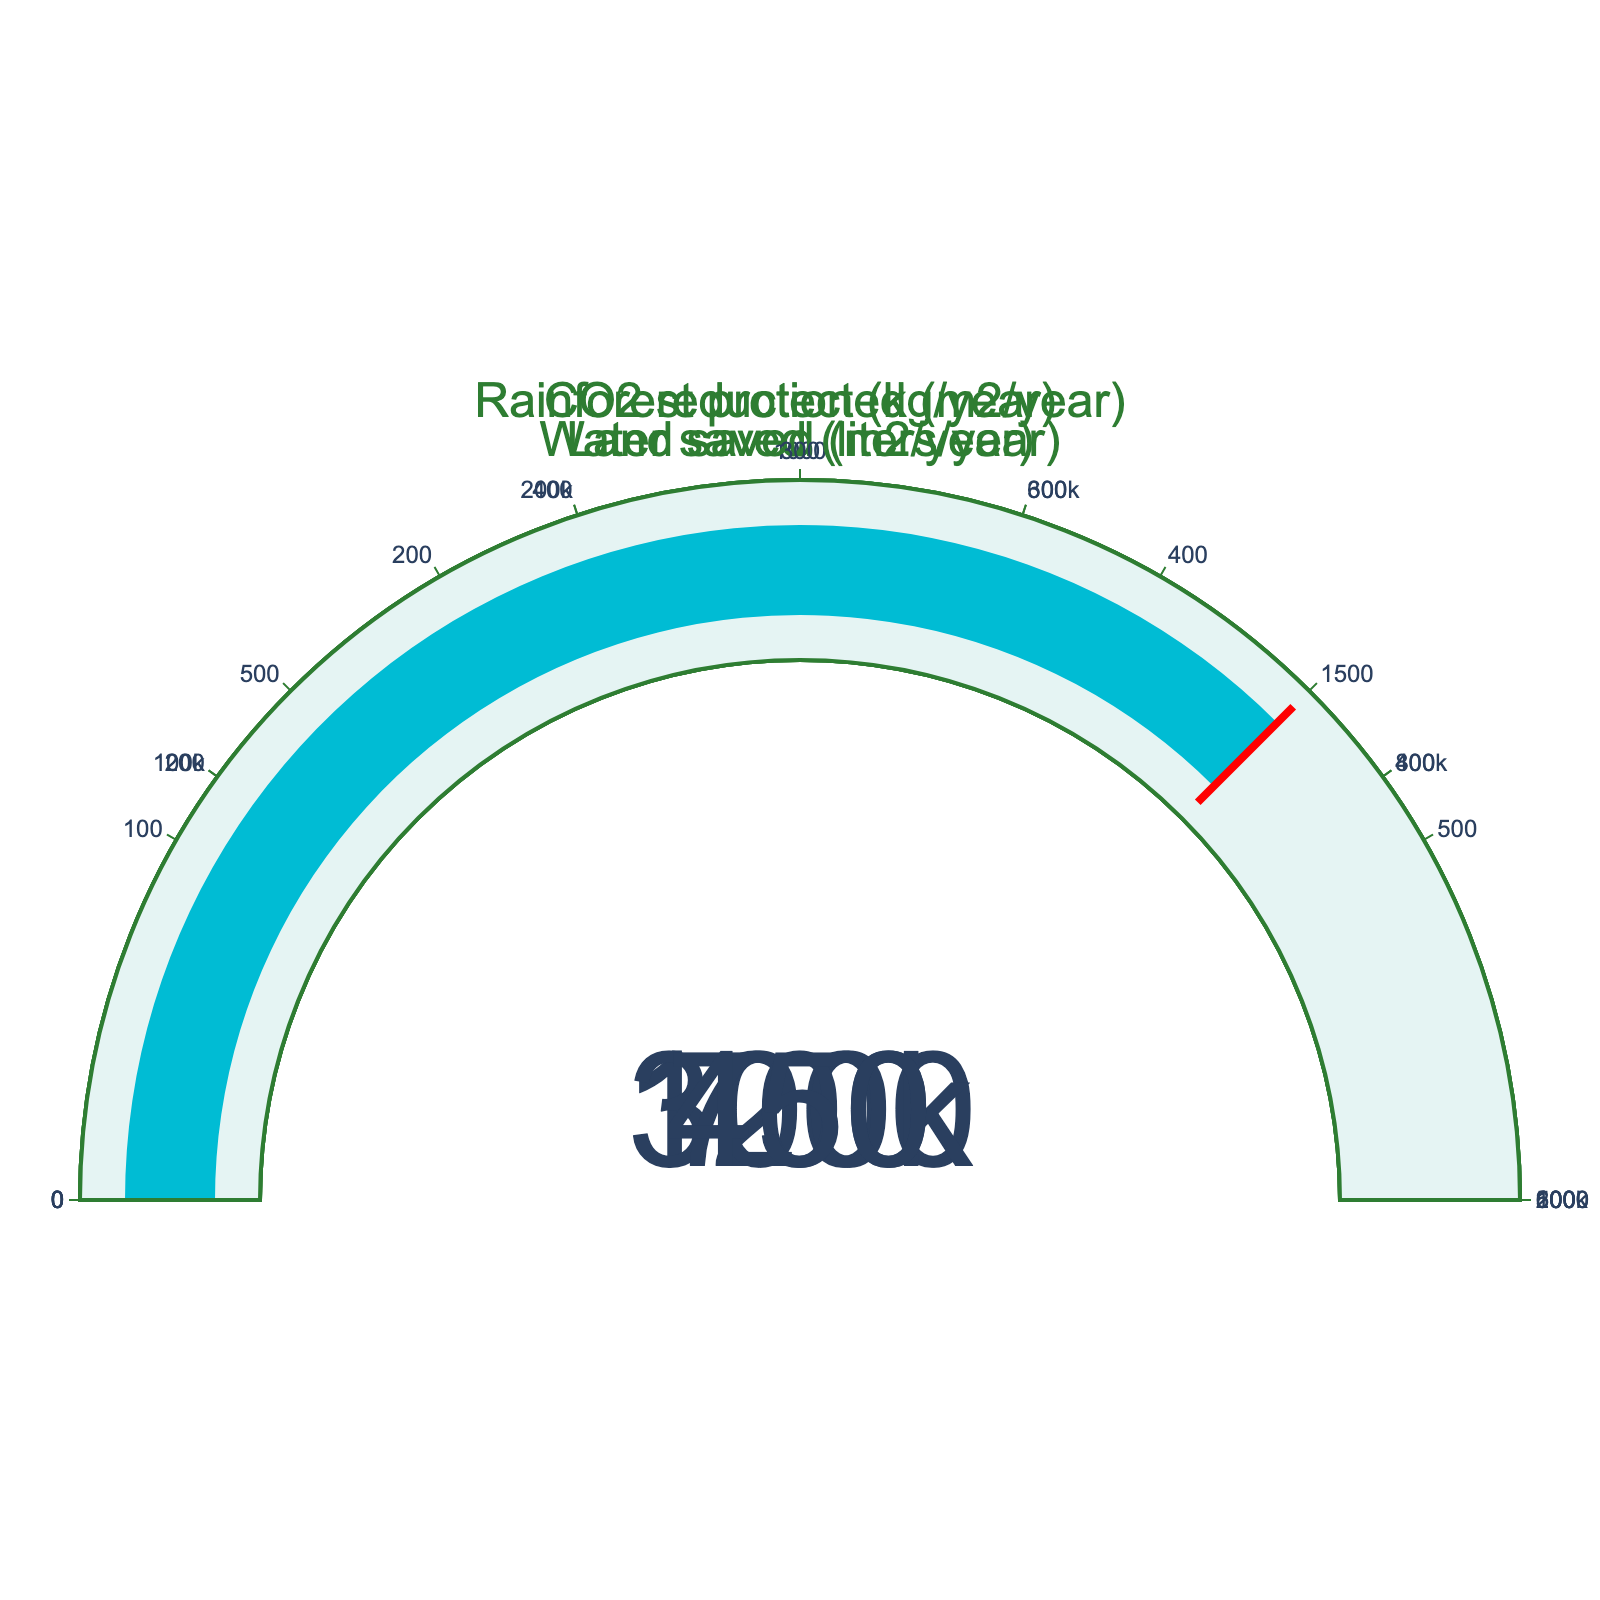What is the amount of CO2 reduction from a plant-based diet per year? The gauge chart shows the CO2 reduction labeled as "CO2 reduction (kg/year)" with a numerical value displayed.
Answer: 1200 kg/year How much water is saved by a plant-based diet per year? The gauge chart displays the water saved labeled as "Water saved (liters/year)" with the numerical value shown.
Answer: 300,000 liters/year Which category has the highest maximum value? By examining the gauges' maximum scales, "Water saved (liters/year)" has the largest maximum value of 500,000 liters compared to the other categories.
Answer: Water saved (liters/year) By how much can land saved by a plant-based diet increase to reach its maximum? The gauge chart indicates the current value is 700 m2, and the maximum is 1,000 m2. Subtracting these gives 1,000 - 700 = 300.
Answer: 300 m2 Is the value for CO2 reduction nearer to its maximum compared to the value for Rainforest protected? CO2 reduction reaches 1200 out of 2000, which is 60%, while Rainforest protected is at 450 out of 600, which is 75%. Therefore, CO2 reduction is actually further from its maximum.
Answer: No How much more land saved would be required to be equal to Rainforest protected, in numerical value? The current land saved is 700 m2 and Rainforest protected is 450 m2. Subtract these gives 700 - 450 = 250.
Answer: 250 m2 What is the range of values for the Water saved gauge? The gauge chart shows that the range for the Water saved gauge is from 0 to 500,000 liters/year.
Answer: 0 to 500,000 liters/year Which gauge shows a smaller percentage of its max value, CO2 reduction or Water saved? CO2 reduction is 1200 out of 2000 (60%) and Water saved is 300,000 out of 500,000 (60%). Both categories have the same percentage of their max values.
Answer: Both are the same If both CO2 reduction and Rainforest protected values increased by 100 units, which would be closer to its max value? If CO2 reduction increased by 100, it would be 1300 out of 2000 (65%). If Rainforest protected increased by 100, it would be 550 out of 600 (91.67%). Rainforest protected would still be closer to its maximum.
Answer: Rainforest protected What is the total saved m2 for both Land and Rainforest protected by a plant-based diet per year? Adding the values of Land saved (700 m2) and Rainforest protected (450 m2) gives 700 + 450 = 1,150 m2.
Answer: 1,150 m2 